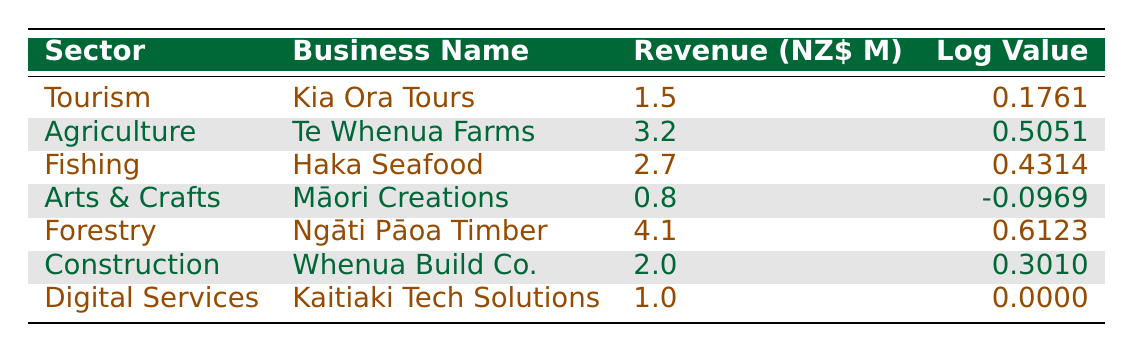What is the revenue of Kia Ora Tours? The table shows that under the Tourism sector, the business name "Kia Ora Tours" has a revenue of 1.5 million NZD listed in the Revenue column.
Answer: 1.5 million NZD Which sector has the highest revenue? By examining the Revenue column, the sector "Forestry" has the highest revenue of 4.1 million NZD, compared to the other sectors listed.
Answer: Forestry How many businesses have a revenue greater than 2 million NZD? From the table, I can filter the Revenue values and see that "Te Whenua Farms" (3.2), "Haka Seafood" (2.7), and "Ngāti Pāoa Timber" (4.1) all exceed 2 million NZD. This yields a total of three businesses.
Answer: 3 What is the average revenue of all listed Māori-owned businesses? The total revenue across all businesses is (1.5 + 3.2 + 2.7 + 0.8 + 4.1 + 2.0 + 1.0) = 15.3 million NZD. Dividing by the number of businesses (7) gives us an average of 15.3 / 7 = 2.1857 million NZD.
Answer: 2.186 million NZD Is it true that Māori Creations has a positive logarithmic value? Looking at the logarithmic value for "Māori Creations", it is -0.0969, which is clearly negative. Therefore, it is false that it has a positive logarithmic value.
Answer: False What percentage of the total revenue comes from the Construction sector? The total revenue is 15.3 million NZD, and the revenue from "Whenua Build Co." in the Construction sector is 2.0 million NZD. To find the percentage, I calculate (2.0 / 15.3) * 100 ≈ 13.07%.
Answer: 13.07% Which sectors have a revenue less than 1 million NZD? Scanning the Revenue column, I see that "Arts & Crafts" is the only sector that has a revenue of 0.8 million NZD, which is less than 1 million NZD.
Answer: Arts & Crafts What is the difference in logarithmic values between the highest and lowest values? The highest logarithmic value is for "Ngāti Pāoa Timber" at 0.6123, and the lowest is "Māori Creations" at -0.0969. Calculating the difference: 0.6123 - (-0.0969) = 0.6123 + 0.0969 = 0.7092.
Answer: 0.7092 